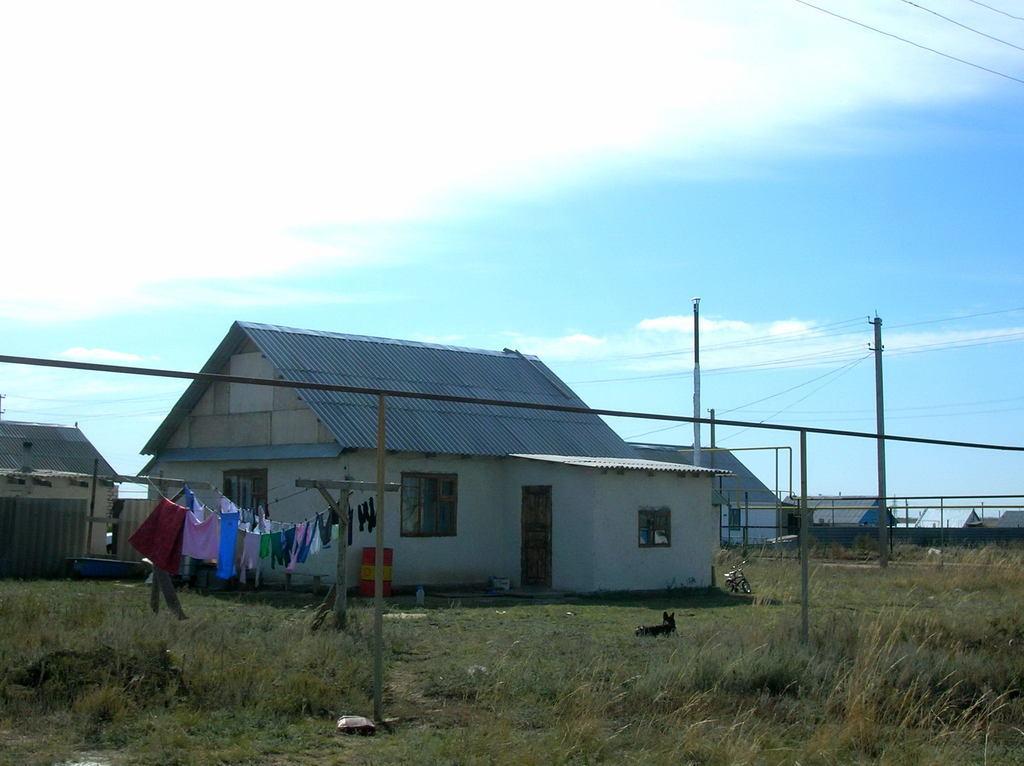In one or two sentences, can you explain what this image depicts? In this image there are houses, metal rods and electric poles with cables on it, in front of the house there are some objects, a dog and there are clothes hanged on a rope, on the top of the image there are clouds in the sky. 